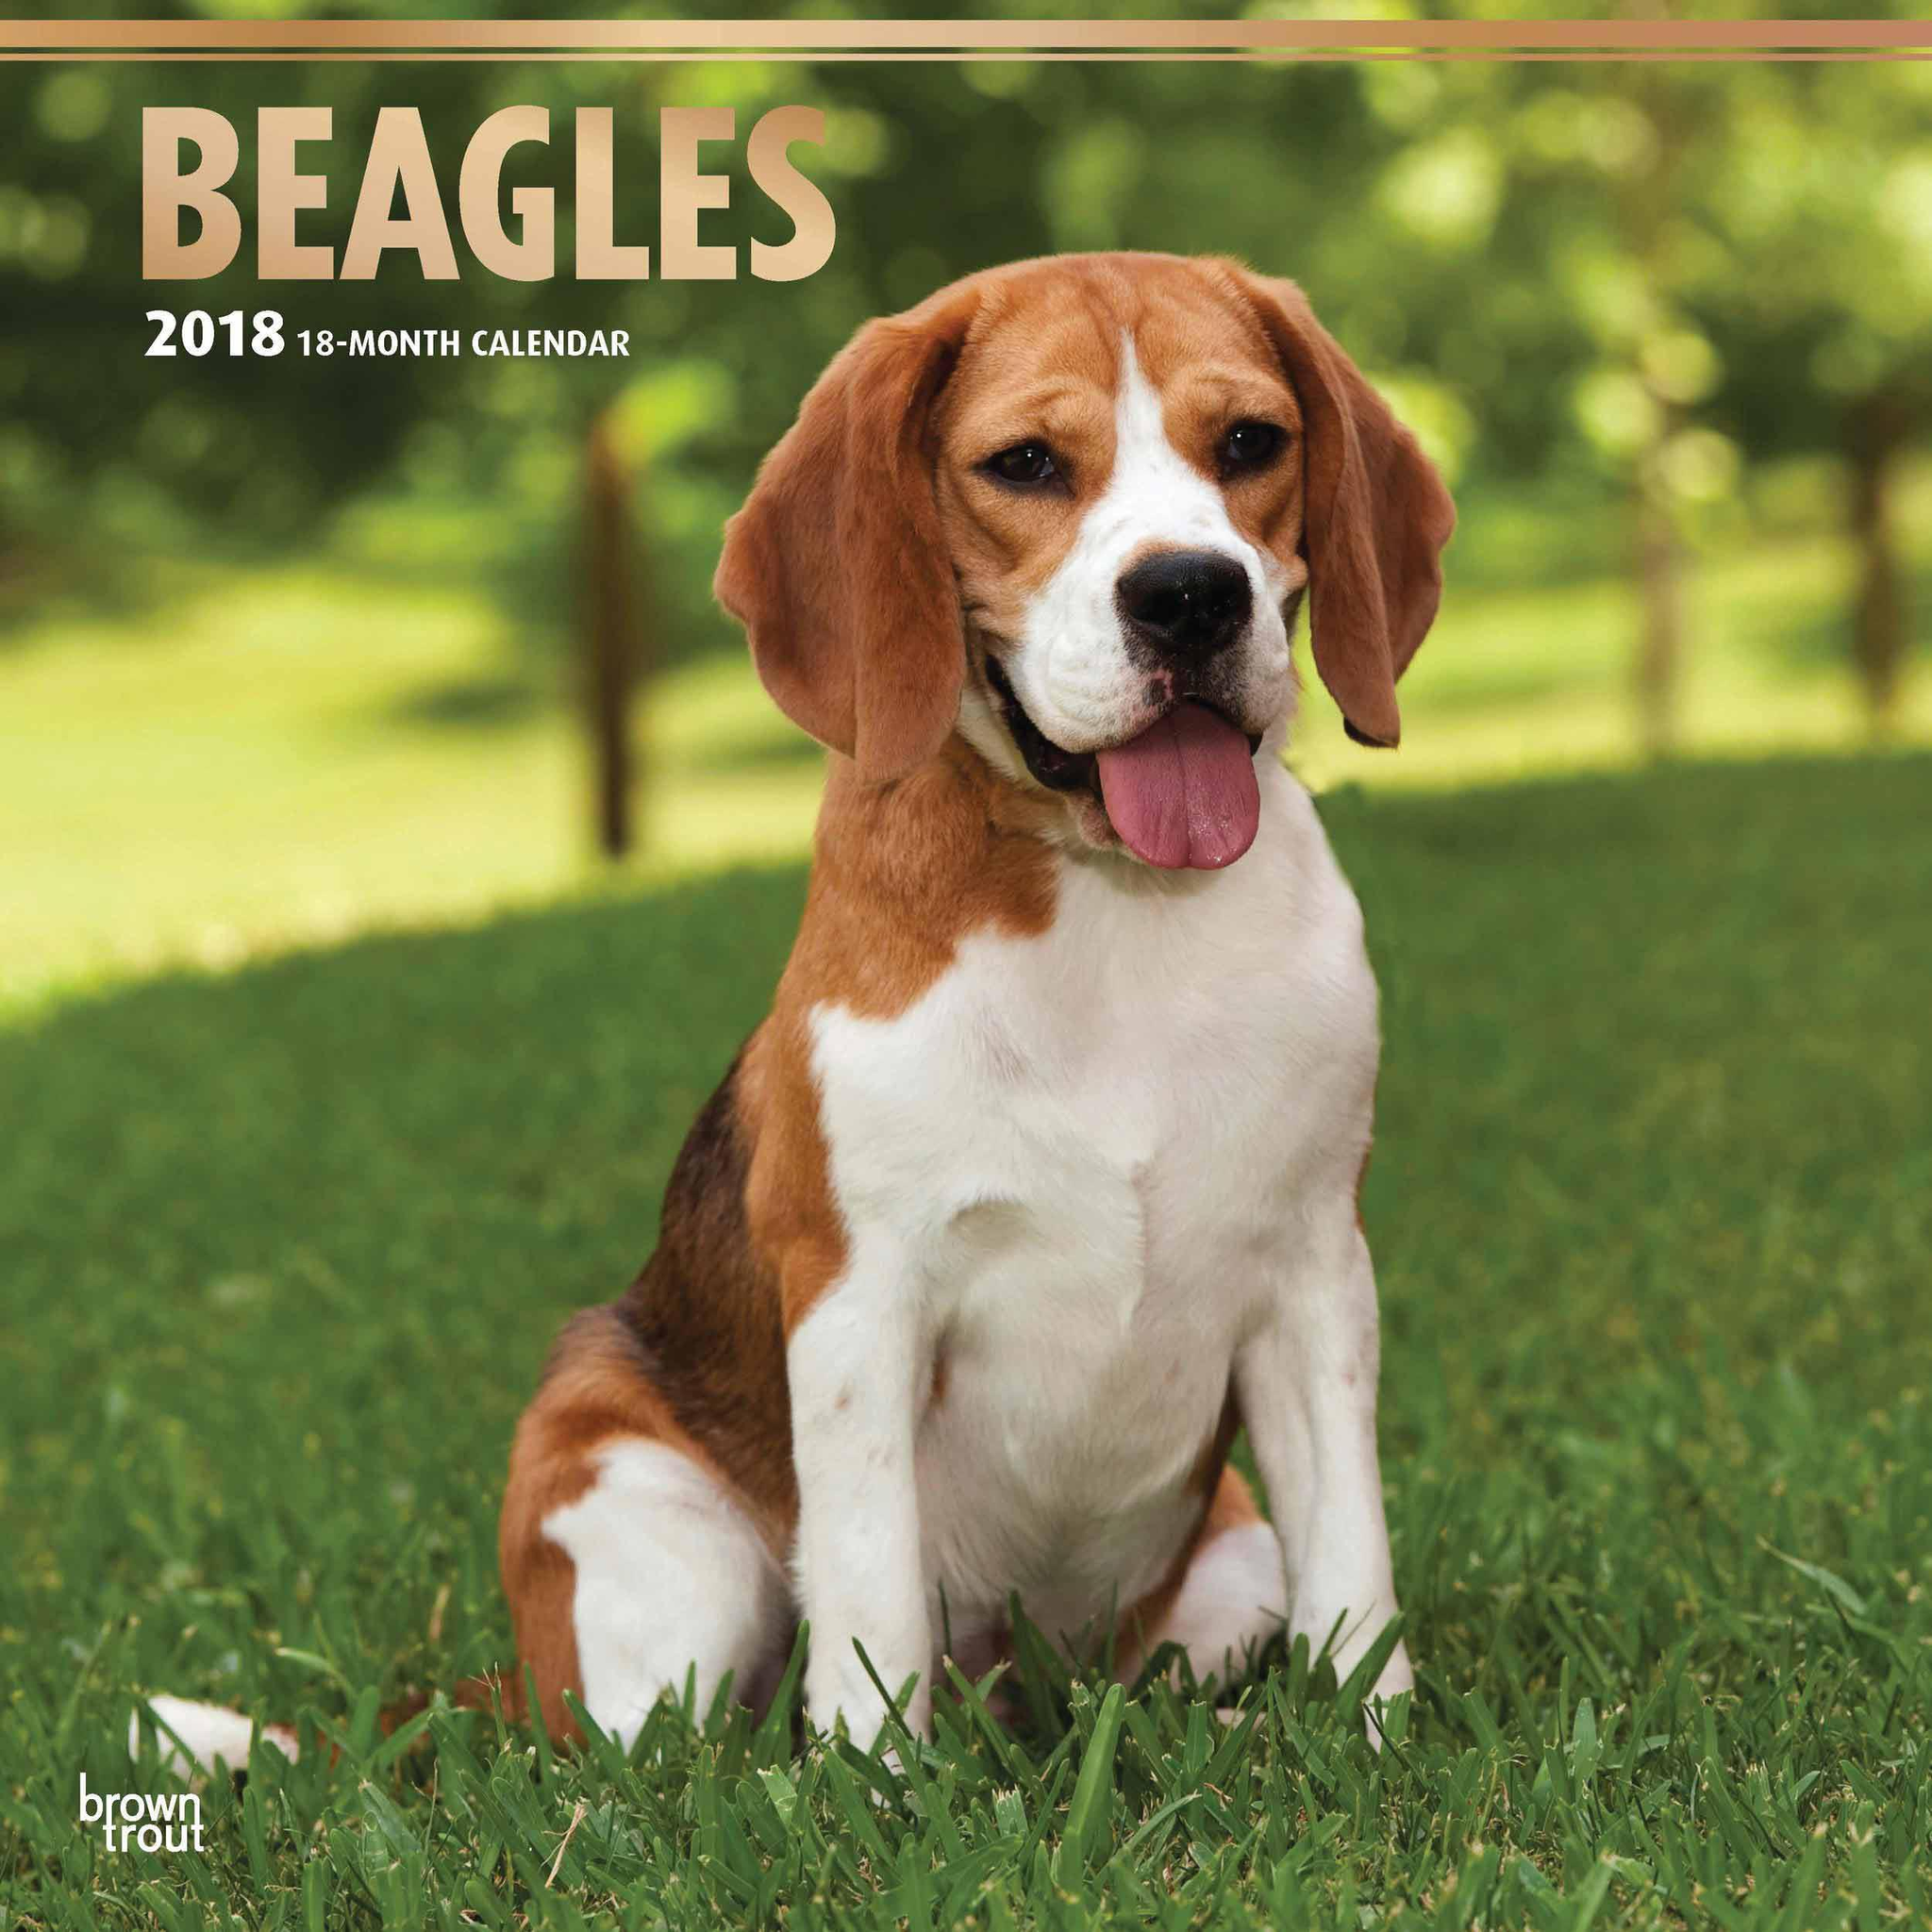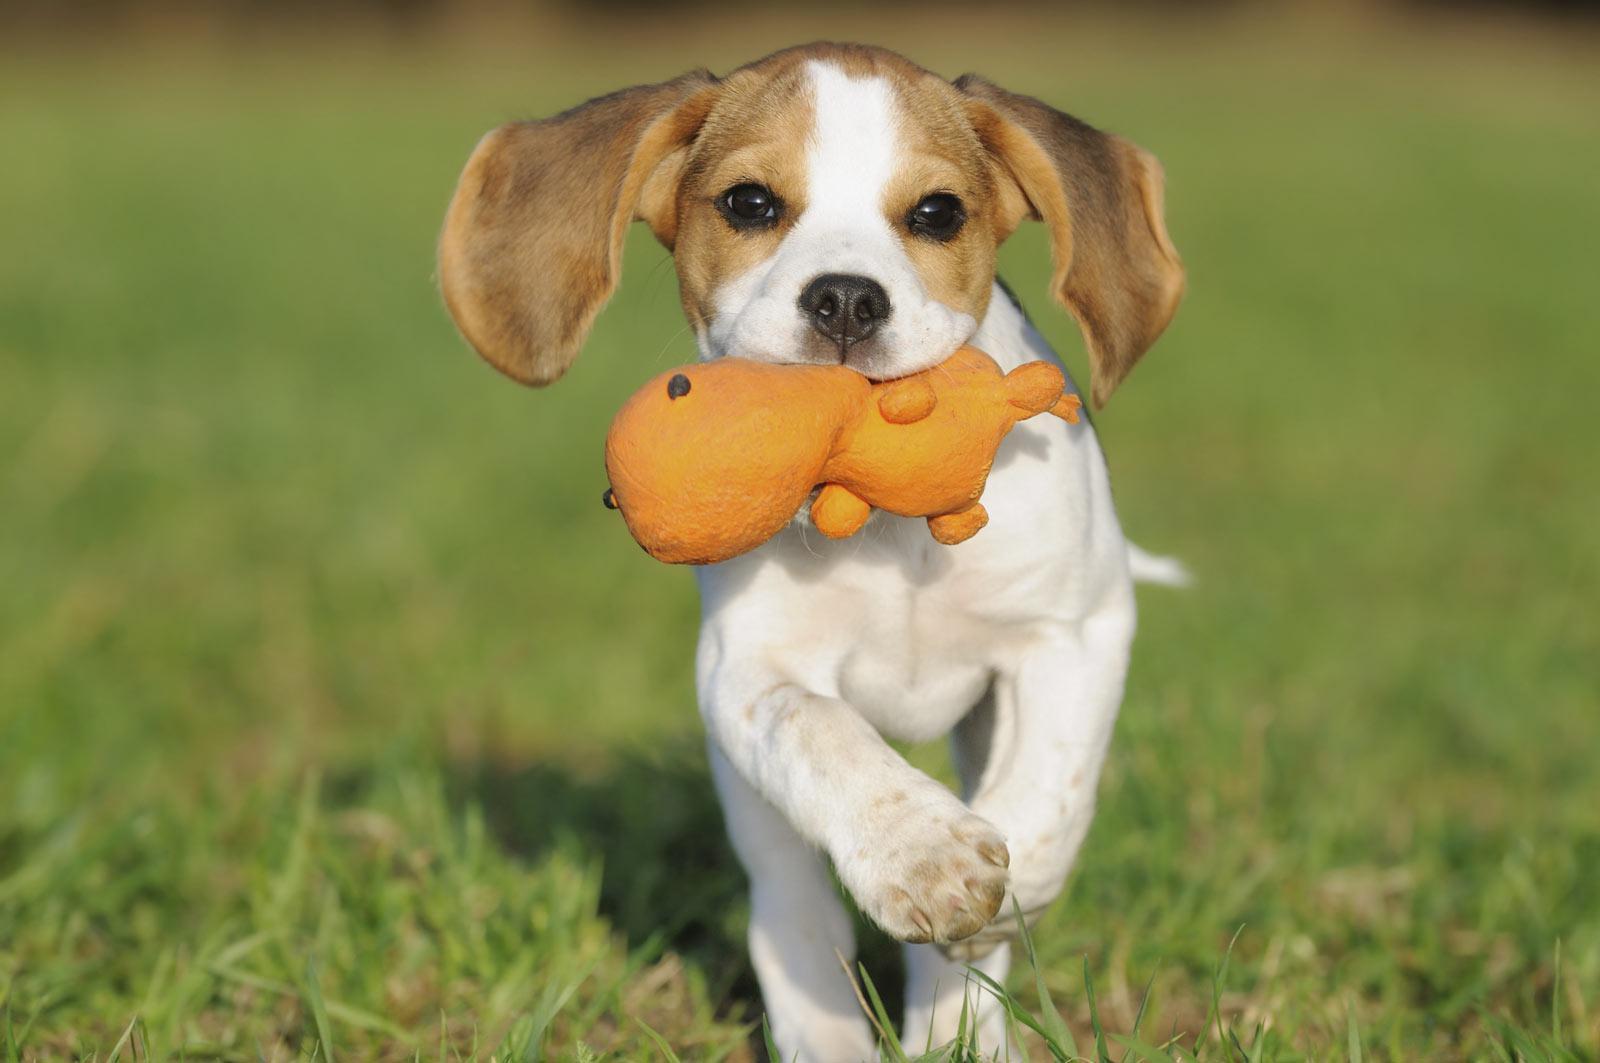The first image is the image on the left, the second image is the image on the right. For the images displayed, is the sentence "There are exactly four dogs, and at least two of them seem to be puppies." factually correct? Answer yes or no. No. 